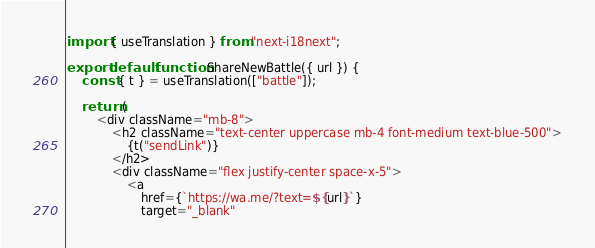<code> <loc_0><loc_0><loc_500><loc_500><_JavaScript_>import { useTranslation } from "next-i18next";

export default function ShareNewBattle({ url }) {
    const { t } = useTranslation(["battle"]);

    return (
        <div className="mb-8">
            <h2 className="text-center uppercase mb-4 font-medium text-blue-500">
                {t("sendLink")}
            </h2>
            <div className="flex justify-center space-x-5">
                <a
                    href={`https://wa.me/?text=${url}`}
                    target="_blank"</code> 